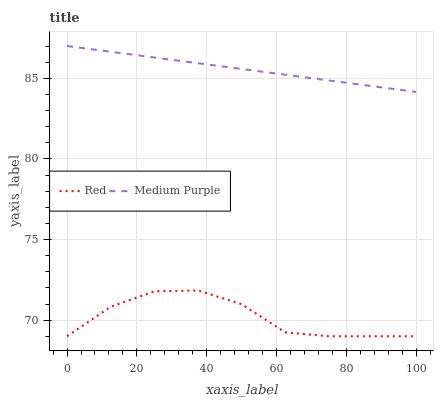Does Red have the minimum area under the curve?
Answer yes or no. Yes. Does Medium Purple have the maximum area under the curve?
Answer yes or no. Yes. Does Red have the maximum area under the curve?
Answer yes or no. No. Is Medium Purple the smoothest?
Answer yes or no. Yes. Is Red the roughest?
Answer yes or no. Yes. Is Red the smoothest?
Answer yes or no. No. Does Red have the lowest value?
Answer yes or no. Yes. Does Medium Purple have the highest value?
Answer yes or no. Yes. Does Red have the highest value?
Answer yes or no. No. Is Red less than Medium Purple?
Answer yes or no. Yes. Is Medium Purple greater than Red?
Answer yes or no. Yes. Does Red intersect Medium Purple?
Answer yes or no. No. 